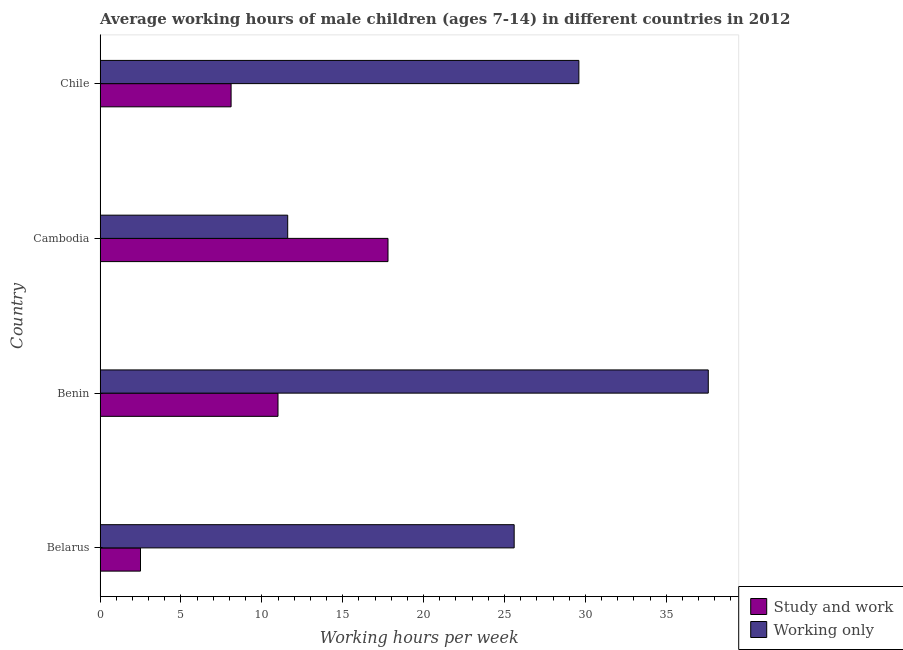How many groups of bars are there?
Offer a terse response. 4. Are the number of bars per tick equal to the number of legend labels?
Ensure brevity in your answer.  Yes. Are the number of bars on each tick of the Y-axis equal?
Give a very brief answer. Yes. How many bars are there on the 1st tick from the bottom?
Offer a very short reply. 2. What is the label of the 4th group of bars from the top?
Give a very brief answer. Belarus. What is the average working hour of children involved in only work in Belarus?
Offer a terse response. 25.6. Across all countries, what is the maximum average working hour of children involved in only work?
Your answer should be very brief. 37.6. Across all countries, what is the minimum average working hour of children involved in study and work?
Offer a very short reply. 2.5. In which country was the average working hour of children involved in study and work maximum?
Your answer should be compact. Cambodia. In which country was the average working hour of children involved in study and work minimum?
Your answer should be compact. Belarus. What is the total average working hour of children involved in only work in the graph?
Offer a terse response. 104.4. What is the difference between the average working hour of children involved in study and work in Cambodia and that in Chile?
Your response must be concise. 9.7. What is the difference between the average working hour of children involved in study and work in Cambodia and the average working hour of children involved in only work in Chile?
Offer a very short reply. -11.8. What is the average average working hour of children involved in study and work per country?
Give a very brief answer. 9.85. What is the difference between the average working hour of children involved in study and work and average working hour of children involved in only work in Chile?
Offer a terse response. -21.5. What is the ratio of the average working hour of children involved in only work in Belarus to that in Cambodia?
Make the answer very short. 2.21. Is the difference between the average working hour of children involved in study and work in Belarus and Chile greater than the difference between the average working hour of children involved in only work in Belarus and Chile?
Offer a terse response. No. What is the difference between the highest and the second highest average working hour of children involved in only work?
Your answer should be compact. 8. What does the 1st bar from the top in Cambodia represents?
Keep it short and to the point. Working only. What does the 2nd bar from the bottom in Belarus represents?
Your response must be concise. Working only. How many bars are there?
Make the answer very short. 8. How many countries are there in the graph?
Offer a terse response. 4. Does the graph contain grids?
Provide a short and direct response. No. Where does the legend appear in the graph?
Your answer should be very brief. Bottom right. What is the title of the graph?
Ensure brevity in your answer.  Average working hours of male children (ages 7-14) in different countries in 2012. Does "Stunting" appear as one of the legend labels in the graph?
Make the answer very short. No. What is the label or title of the X-axis?
Your response must be concise. Working hours per week. What is the label or title of the Y-axis?
Offer a terse response. Country. What is the Working hours per week of Study and work in Belarus?
Ensure brevity in your answer.  2.5. What is the Working hours per week of Working only in Belarus?
Provide a succinct answer. 25.6. What is the Working hours per week in Working only in Benin?
Your answer should be very brief. 37.6. What is the Working hours per week of Study and work in Chile?
Give a very brief answer. 8.1. What is the Working hours per week of Working only in Chile?
Provide a short and direct response. 29.6. Across all countries, what is the maximum Working hours per week of Study and work?
Your answer should be compact. 17.8. Across all countries, what is the maximum Working hours per week of Working only?
Your response must be concise. 37.6. Across all countries, what is the minimum Working hours per week in Study and work?
Make the answer very short. 2.5. What is the total Working hours per week in Study and work in the graph?
Provide a short and direct response. 39.4. What is the total Working hours per week in Working only in the graph?
Give a very brief answer. 104.4. What is the difference between the Working hours per week of Study and work in Belarus and that in Benin?
Your answer should be compact. -8.5. What is the difference between the Working hours per week of Study and work in Belarus and that in Cambodia?
Your response must be concise. -15.3. What is the difference between the Working hours per week of Working only in Belarus and that in Cambodia?
Your answer should be very brief. 14. What is the difference between the Working hours per week in Study and work in Benin and that in Chile?
Offer a very short reply. 2.9. What is the difference between the Working hours per week of Study and work in Belarus and the Working hours per week of Working only in Benin?
Give a very brief answer. -35.1. What is the difference between the Working hours per week in Study and work in Belarus and the Working hours per week in Working only in Chile?
Make the answer very short. -27.1. What is the difference between the Working hours per week of Study and work in Benin and the Working hours per week of Working only in Cambodia?
Ensure brevity in your answer.  -0.6. What is the difference between the Working hours per week of Study and work in Benin and the Working hours per week of Working only in Chile?
Make the answer very short. -18.6. What is the difference between the Working hours per week in Study and work in Cambodia and the Working hours per week in Working only in Chile?
Offer a very short reply. -11.8. What is the average Working hours per week in Study and work per country?
Your response must be concise. 9.85. What is the average Working hours per week of Working only per country?
Ensure brevity in your answer.  26.1. What is the difference between the Working hours per week in Study and work and Working hours per week in Working only in Belarus?
Your response must be concise. -23.1. What is the difference between the Working hours per week in Study and work and Working hours per week in Working only in Benin?
Make the answer very short. -26.6. What is the difference between the Working hours per week of Study and work and Working hours per week of Working only in Chile?
Provide a short and direct response. -21.5. What is the ratio of the Working hours per week in Study and work in Belarus to that in Benin?
Offer a very short reply. 0.23. What is the ratio of the Working hours per week in Working only in Belarus to that in Benin?
Your answer should be very brief. 0.68. What is the ratio of the Working hours per week in Study and work in Belarus to that in Cambodia?
Your answer should be compact. 0.14. What is the ratio of the Working hours per week in Working only in Belarus to that in Cambodia?
Offer a very short reply. 2.21. What is the ratio of the Working hours per week in Study and work in Belarus to that in Chile?
Give a very brief answer. 0.31. What is the ratio of the Working hours per week of Working only in Belarus to that in Chile?
Your answer should be very brief. 0.86. What is the ratio of the Working hours per week of Study and work in Benin to that in Cambodia?
Provide a succinct answer. 0.62. What is the ratio of the Working hours per week in Working only in Benin to that in Cambodia?
Give a very brief answer. 3.24. What is the ratio of the Working hours per week of Study and work in Benin to that in Chile?
Give a very brief answer. 1.36. What is the ratio of the Working hours per week of Working only in Benin to that in Chile?
Offer a terse response. 1.27. What is the ratio of the Working hours per week of Study and work in Cambodia to that in Chile?
Ensure brevity in your answer.  2.2. What is the ratio of the Working hours per week in Working only in Cambodia to that in Chile?
Your answer should be compact. 0.39. What is the difference between the highest and the lowest Working hours per week in Study and work?
Make the answer very short. 15.3. What is the difference between the highest and the lowest Working hours per week of Working only?
Your response must be concise. 26. 